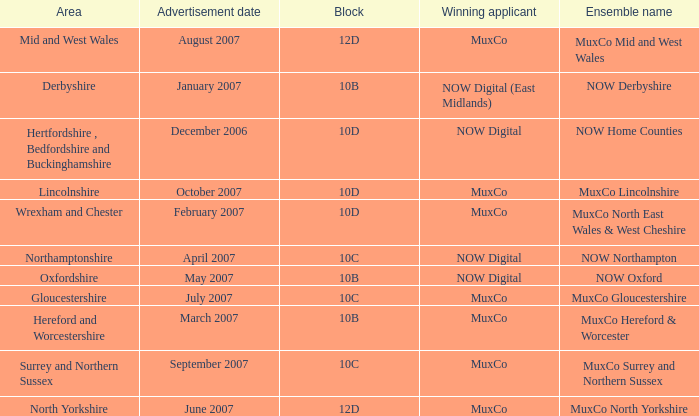Parse the full table. {'header': ['Area', 'Advertisement date', 'Block', 'Winning applicant', 'Ensemble name'], 'rows': [['Mid and West Wales', 'August 2007', '12D', 'MuxCo', 'MuxCo Mid and West Wales'], ['Derbyshire', 'January 2007', '10B', 'NOW Digital (East Midlands)', 'NOW Derbyshire'], ['Hertfordshire , Bedfordshire and Buckinghamshire', 'December 2006', '10D', 'NOW Digital', 'NOW Home Counties'], ['Lincolnshire', 'October 2007', '10D', 'MuxCo', 'MuxCo Lincolnshire'], ['Wrexham and Chester', 'February 2007', '10D', 'MuxCo', 'MuxCo North East Wales & West Cheshire'], ['Northamptonshire', 'April 2007', '10C', 'NOW Digital', 'NOW Northampton'], ['Oxfordshire', 'May 2007', '10B', 'NOW Digital', 'NOW Oxford'], ['Gloucestershire', 'July 2007', '10C', 'MuxCo', 'MuxCo Gloucestershire'], ['Hereford and Worcestershire', 'March 2007', '10B', 'MuxCo', 'MuxCo Hereford & Worcester'], ['Surrey and Northern Sussex', 'September 2007', '10C', 'MuxCo', 'MuxCo Surrey and Northern Sussex'], ['North Yorkshire', 'June 2007', '12D', 'MuxCo', 'MuxCo North Yorkshire']]} Who is the Winning Applicant of Ensemble Name Muxco Lincolnshire in Block 10D? MuxCo. 